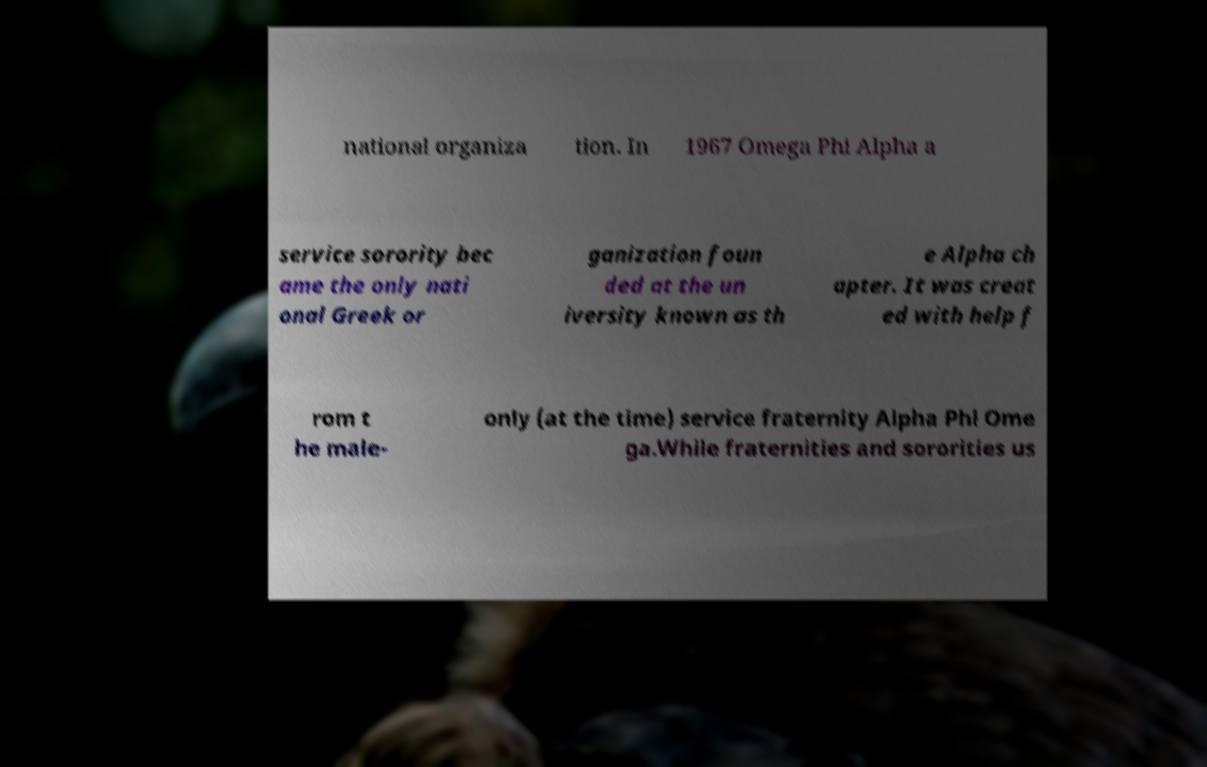For documentation purposes, I need the text within this image transcribed. Could you provide that? national organiza tion. In 1967 Omega Phi Alpha a service sorority bec ame the only nati onal Greek or ganization foun ded at the un iversity known as th e Alpha ch apter. It was creat ed with help f rom t he male- only (at the time) service fraternity Alpha Phi Ome ga.While fraternities and sororities us 